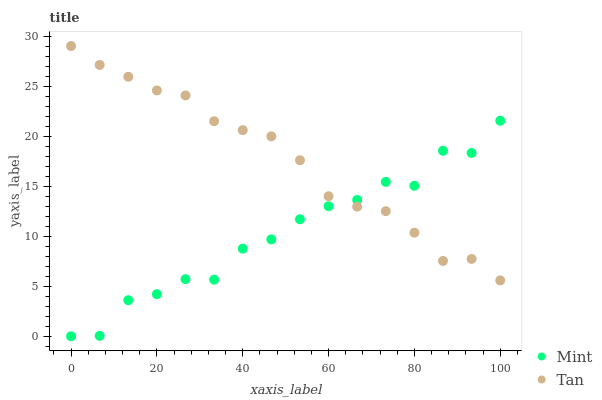Does Mint have the minimum area under the curve?
Answer yes or no. Yes. Does Tan have the maximum area under the curve?
Answer yes or no. Yes. Does Mint have the maximum area under the curve?
Answer yes or no. No. Is Tan the smoothest?
Answer yes or no. Yes. Is Mint the roughest?
Answer yes or no. Yes. Is Mint the smoothest?
Answer yes or no. No. Does Mint have the lowest value?
Answer yes or no. Yes. Does Tan have the highest value?
Answer yes or no. Yes. Does Mint have the highest value?
Answer yes or no. No. Does Mint intersect Tan?
Answer yes or no. Yes. Is Mint less than Tan?
Answer yes or no. No. Is Mint greater than Tan?
Answer yes or no. No. 